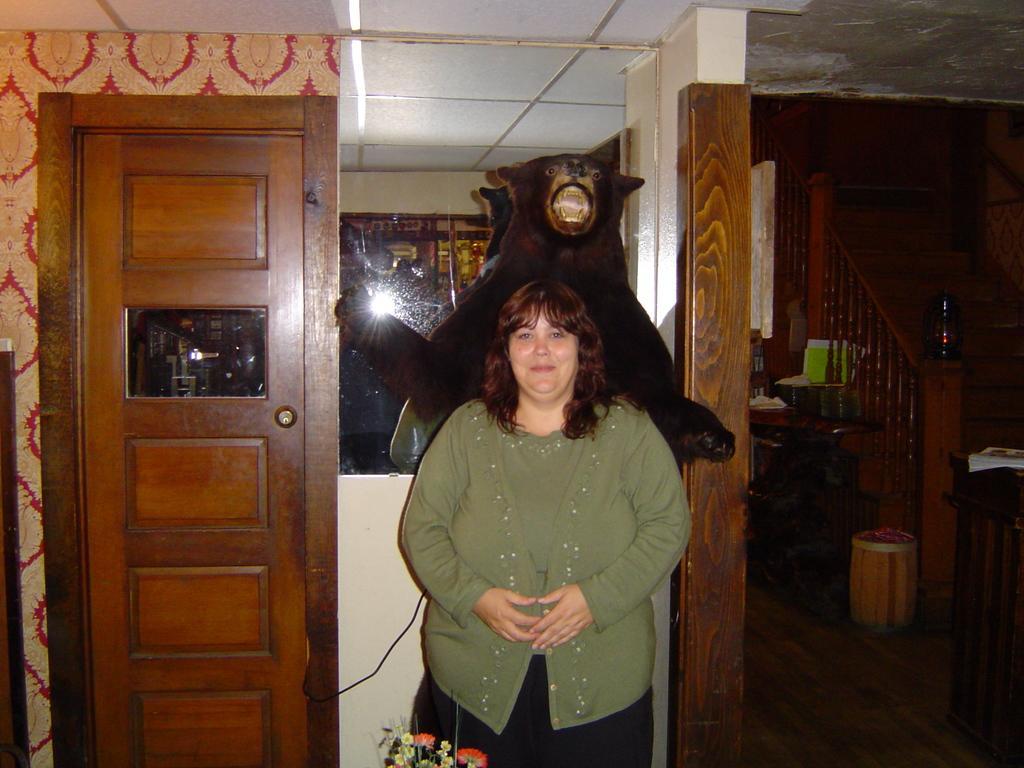Please provide a concise description of this image. In the picture,there is a woman standing beside a cupboard and behind the woman there is a black bear,behind the bear there is a mirror and in the right side there are wooden stairs. 